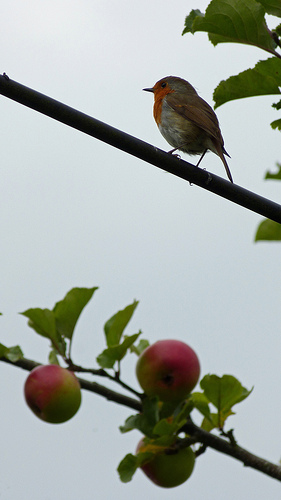Could you tell me more about the habitat of the bird shown? Certainly! The European Robin is often found in woodland areas, gardens, and parks. They typically prefer habitats with dense vegetation where they can forage for insects and worms. 